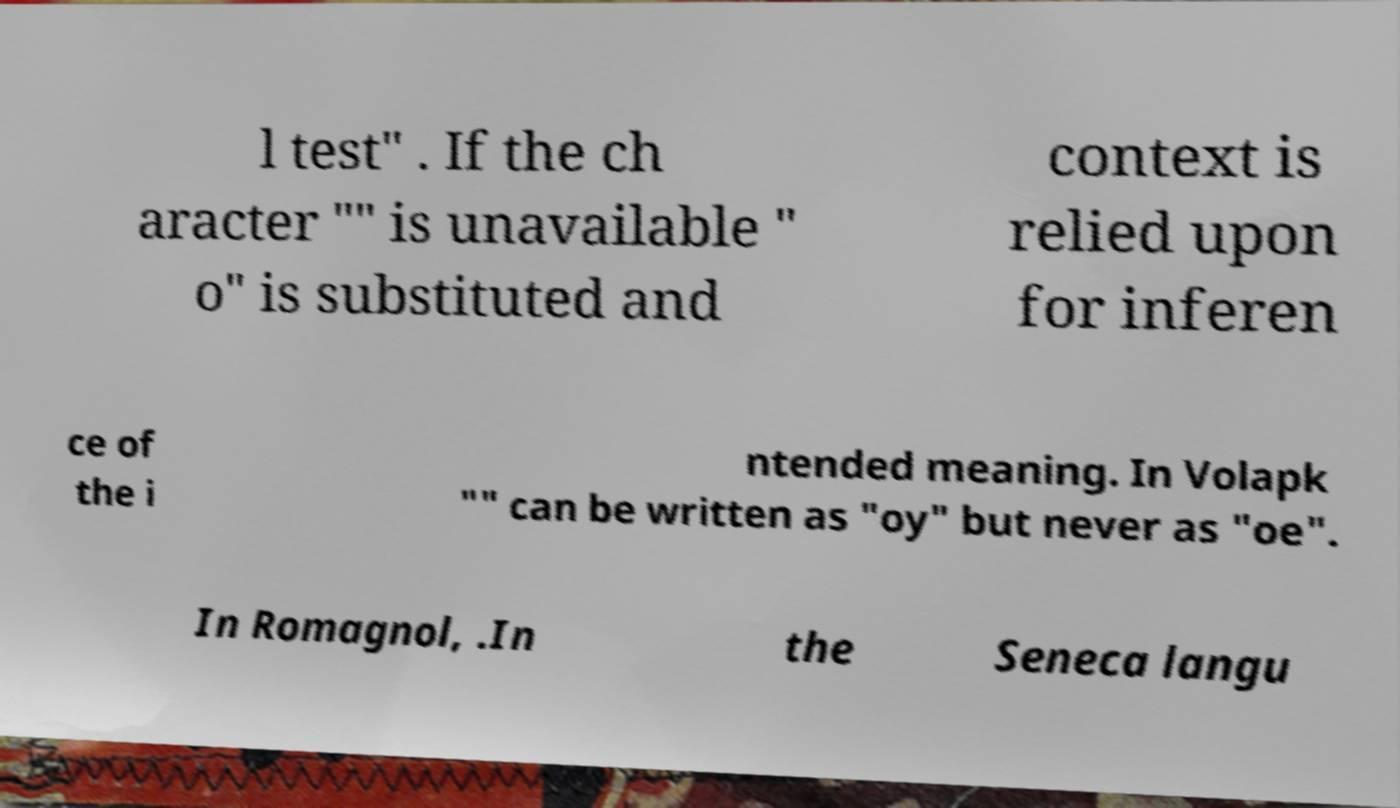Could you assist in decoding the text presented in this image and type it out clearly? l test" . If the ch aracter "" is unavailable " o" is substituted and context is relied upon for inferen ce of the i ntended meaning. In Volapk "" can be written as "oy" but never as "oe". In Romagnol, .In the Seneca langu 